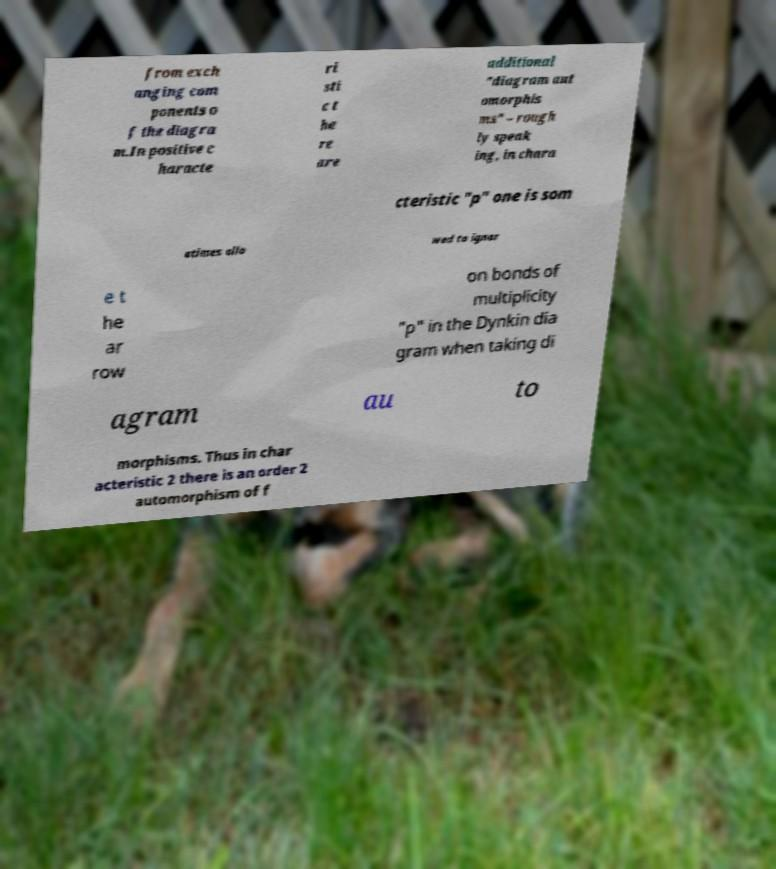Please identify and transcribe the text found in this image. from exch anging com ponents o f the diagra m.In positive c haracte ri sti c t he re are additional "diagram aut omorphis ms" – rough ly speak ing, in chara cteristic "p" one is som etimes allo wed to ignor e t he ar row on bonds of multiplicity "p" in the Dynkin dia gram when taking di agram au to morphisms. Thus in char acteristic 2 there is an order 2 automorphism of f 